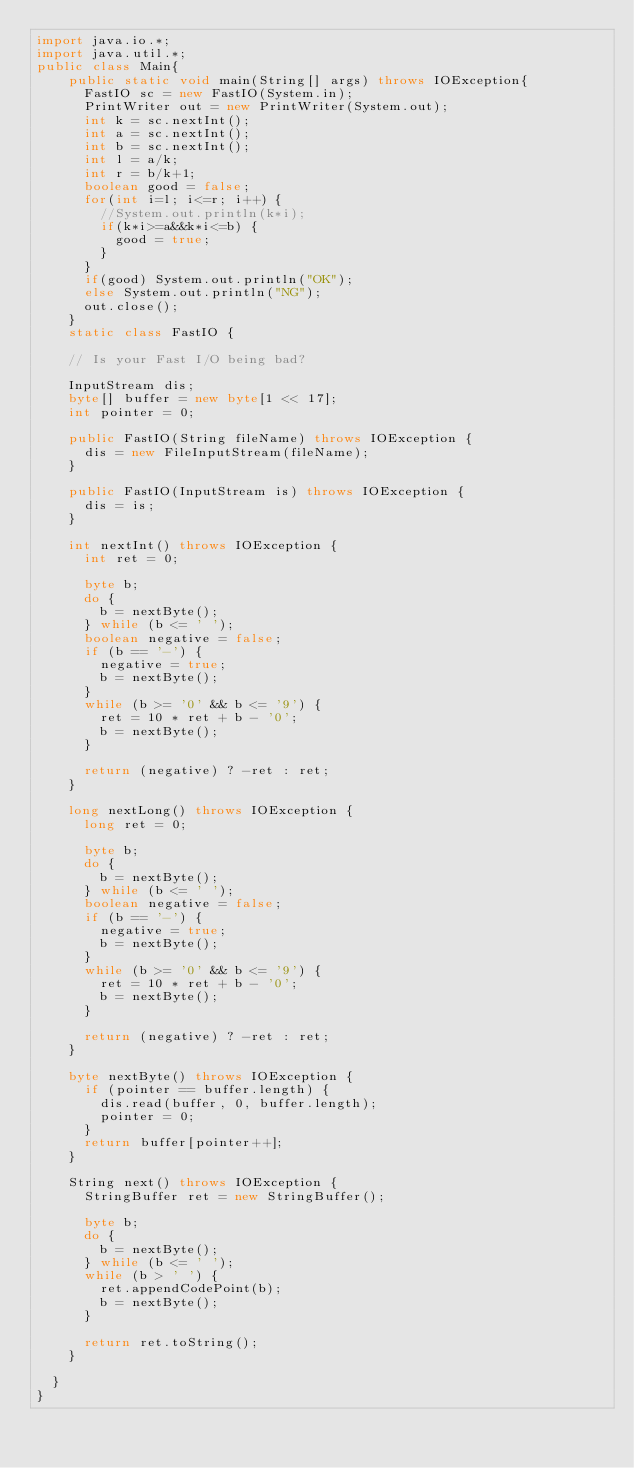<code> <loc_0><loc_0><loc_500><loc_500><_Java_>import java.io.*;
import java.util.*;
public class Main{
    public static void main(String[] args) throws IOException{
    	FastIO sc = new FastIO(System.in);
    	PrintWriter out = new PrintWriter(System.out);
    	int k = sc.nextInt();
    	int a = sc.nextInt();
    	int b = sc.nextInt();
    	int l = a/k;
    	int r = b/k+1;
    	boolean good = false;
    	for(int i=l; i<=r; i++) {
    		//System.out.println(k*i);
    		if(k*i>=a&&k*i<=b) {
    			good = true;
    		}
    	}
     	if(good) System.out.println("OK");
     	else System.out.println("NG");
    	out.close();
    }
    static class FastIO {
		 
		// Is your Fast I/O being bad?
 
		InputStream dis;
		byte[] buffer = new byte[1 << 17];
		int pointer = 0;
 
		public FastIO(String fileName) throws IOException {
			dis = new FileInputStream(fileName);
		}
 
		public FastIO(InputStream is) throws IOException {
			dis = is;
		}
 
		int nextInt() throws IOException {
			int ret = 0;
 
			byte b;
			do {
				b = nextByte();
			} while (b <= ' ');
			boolean negative = false;
			if (b == '-') {
				negative = true;
				b = nextByte();
			}
			while (b >= '0' && b <= '9') {
				ret = 10 * ret + b - '0';
				b = nextByte();
			}
 
			return (negative) ? -ret : ret;
		}
 
		long nextLong() throws IOException {
			long ret = 0;
 
			byte b;
			do {
				b = nextByte();
			} while (b <= ' ');
			boolean negative = false;
			if (b == '-') {
				negative = true;
				b = nextByte();
			}
			while (b >= '0' && b <= '9') {
				ret = 10 * ret + b - '0';
				b = nextByte();
			}
 
			return (negative) ? -ret : ret;
		}
 
		byte nextByte() throws IOException {
			if (pointer == buffer.length) {
				dis.read(buffer, 0, buffer.length);
				pointer = 0;
			}
			return buffer[pointer++];
		}
 
		String next() throws IOException {
			StringBuffer ret = new StringBuffer();
 
			byte b;
			do {
				b = nextByte();
			} while (b <= ' ');
			while (b > ' ') {
				ret.appendCodePoint(b);
				b = nextByte();
			}
 
			return ret.toString();
		}
 
	}
}</code> 